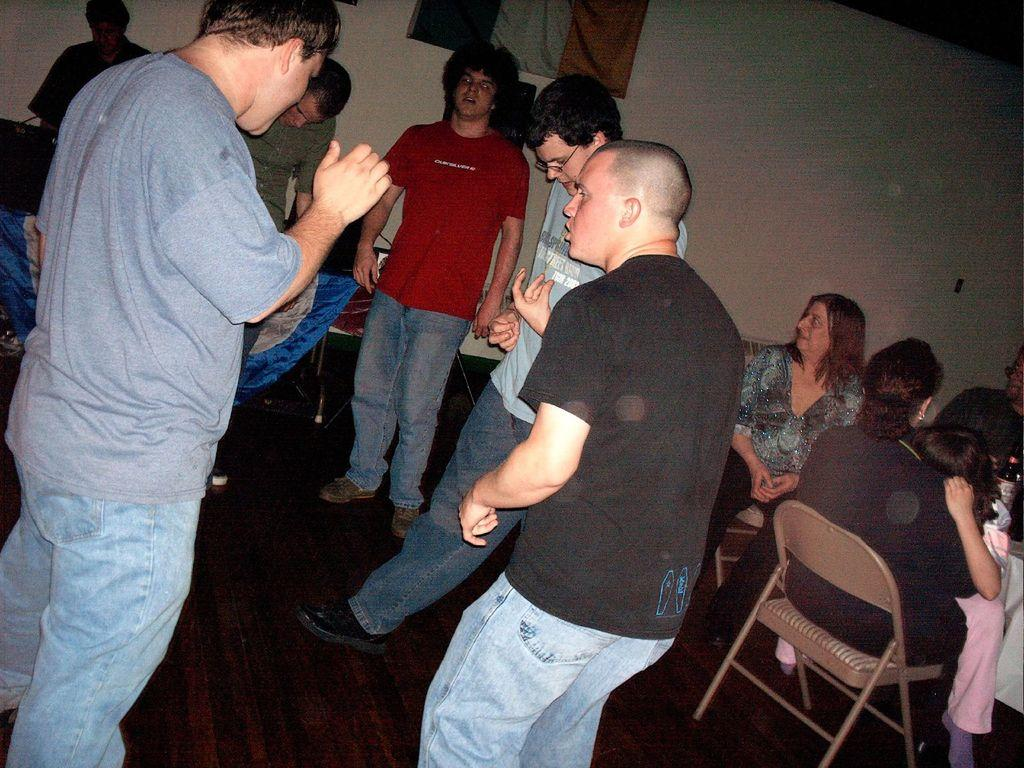What are the persons in the image doing? There are persons standing on the floor and two persons sitting on chairs in the image. What can be seen in the background of the image? There is a wall and cloth in the background of the image. How many flies can be seen on the cloth in the image? There are no flies visible in the image; only the wall and cloth are present in the background. What type of trade is being conducted between the persons in the image? There is no indication of any trade or transaction taking place between the persons in the image. 